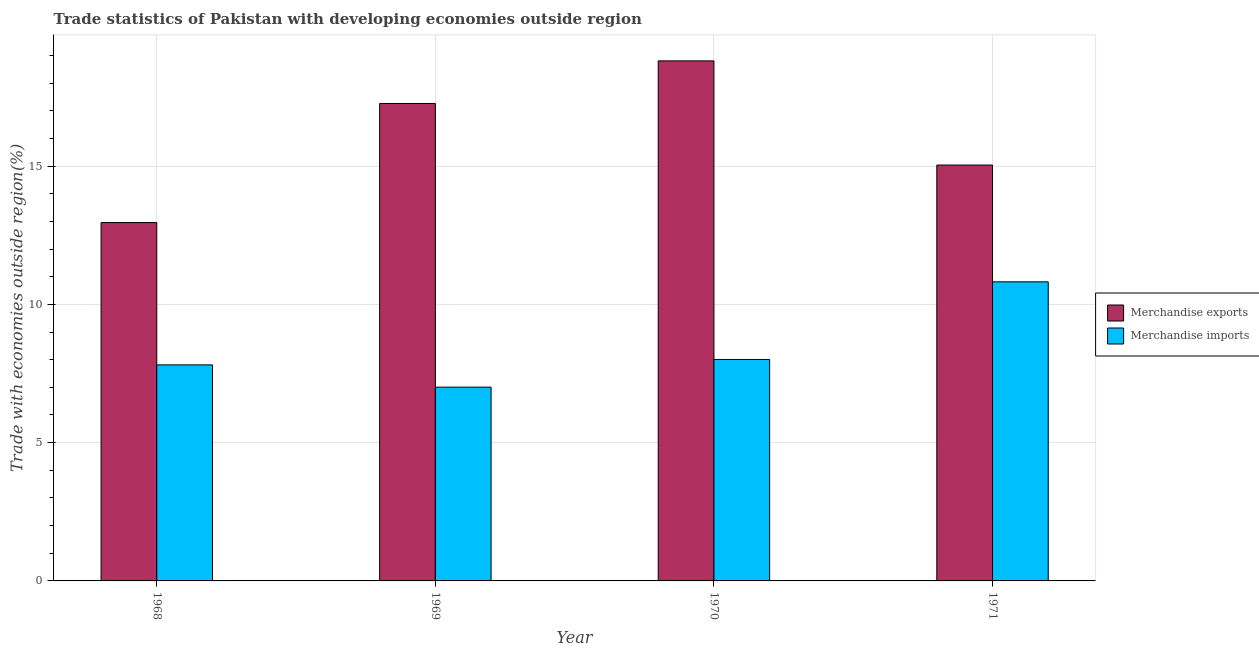How many different coloured bars are there?
Your answer should be compact. 2. How many bars are there on the 2nd tick from the right?
Your answer should be very brief. 2. What is the label of the 1st group of bars from the left?
Provide a short and direct response. 1968. What is the merchandise exports in 1971?
Offer a very short reply. 15.04. Across all years, what is the maximum merchandise exports?
Offer a terse response. 18.8. Across all years, what is the minimum merchandise exports?
Make the answer very short. 12.96. In which year was the merchandise imports maximum?
Ensure brevity in your answer.  1971. In which year was the merchandise imports minimum?
Provide a succinct answer. 1969. What is the total merchandise exports in the graph?
Your answer should be very brief. 64.06. What is the difference between the merchandise exports in 1968 and that in 1969?
Provide a succinct answer. -4.31. What is the difference between the merchandise exports in 1969 and the merchandise imports in 1970?
Your answer should be very brief. -1.54. What is the average merchandise exports per year?
Your response must be concise. 16.02. In the year 1971, what is the difference between the merchandise imports and merchandise exports?
Your answer should be compact. 0. In how many years, is the merchandise imports greater than 4 %?
Provide a short and direct response. 4. What is the ratio of the merchandise imports in 1969 to that in 1970?
Provide a short and direct response. 0.88. What is the difference between the highest and the second highest merchandise imports?
Keep it short and to the point. 2.81. What is the difference between the highest and the lowest merchandise imports?
Make the answer very short. 3.81. Is the sum of the merchandise imports in 1970 and 1971 greater than the maximum merchandise exports across all years?
Offer a terse response. Yes. What does the 2nd bar from the left in 1971 represents?
Your response must be concise. Merchandise imports. What does the 2nd bar from the right in 1971 represents?
Offer a terse response. Merchandise exports. How many bars are there?
Give a very brief answer. 8. How many years are there in the graph?
Provide a short and direct response. 4. What is the difference between two consecutive major ticks on the Y-axis?
Offer a terse response. 5. Are the values on the major ticks of Y-axis written in scientific E-notation?
Your response must be concise. No. Where does the legend appear in the graph?
Provide a short and direct response. Center right. How many legend labels are there?
Your answer should be compact. 2. How are the legend labels stacked?
Offer a terse response. Vertical. What is the title of the graph?
Offer a terse response. Trade statistics of Pakistan with developing economies outside region. What is the label or title of the Y-axis?
Keep it short and to the point. Trade with economies outside region(%). What is the Trade with economies outside region(%) of Merchandise exports in 1968?
Provide a succinct answer. 12.96. What is the Trade with economies outside region(%) in Merchandise imports in 1968?
Offer a terse response. 7.81. What is the Trade with economies outside region(%) in Merchandise exports in 1969?
Offer a very short reply. 17.26. What is the Trade with economies outside region(%) of Merchandise imports in 1969?
Give a very brief answer. 7.01. What is the Trade with economies outside region(%) in Merchandise exports in 1970?
Keep it short and to the point. 18.8. What is the Trade with economies outside region(%) of Merchandise imports in 1970?
Provide a short and direct response. 8.01. What is the Trade with economies outside region(%) in Merchandise exports in 1971?
Your answer should be compact. 15.04. What is the Trade with economies outside region(%) of Merchandise imports in 1971?
Your response must be concise. 10.81. Across all years, what is the maximum Trade with economies outside region(%) in Merchandise exports?
Keep it short and to the point. 18.8. Across all years, what is the maximum Trade with economies outside region(%) of Merchandise imports?
Provide a short and direct response. 10.81. Across all years, what is the minimum Trade with economies outside region(%) in Merchandise exports?
Provide a succinct answer. 12.96. Across all years, what is the minimum Trade with economies outside region(%) of Merchandise imports?
Your answer should be compact. 7.01. What is the total Trade with economies outside region(%) in Merchandise exports in the graph?
Your response must be concise. 64.06. What is the total Trade with economies outside region(%) in Merchandise imports in the graph?
Ensure brevity in your answer.  33.64. What is the difference between the Trade with economies outside region(%) in Merchandise exports in 1968 and that in 1969?
Provide a succinct answer. -4.31. What is the difference between the Trade with economies outside region(%) in Merchandise imports in 1968 and that in 1969?
Offer a very short reply. 0.8. What is the difference between the Trade with economies outside region(%) in Merchandise exports in 1968 and that in 1970?
Offer a very short reply. -5.85. What is the difference between the Trade with economies outside region(%) of Merchandise imports in 1968 and that in 1970?
Offer a terse response. -0.2. What is the difference between the Trade with economies outside region(%) of Merchandise exports in 1968 and that in 1971?
Your answer should be very brief. -2.08. What is the difference between the Trade with economies outside region(%) of Merchandise imports in 1968 and that in 1971?
Your answer should be very brief. -3. What is the difference between the Trade with economies outside region(%) of Merchandise exports in 1969 and that in 1970?
Offer a terse response. -1.54. What is the difference between the Trade with economies outside region(%) of Merchandise imports in 1969 and that in 1970?
Your response must be concise. -1. What is the difference between the Trade with economies outside region(%) in Merchandise exports in 1969 and that in 1971?
Make the answer very short. 2.23. What is the difference between the Trade with economies outside region(%) of Merchandise imports in 1969 and that in 1971?
Provide a succinct answer. -3.81. What is the difference between the Trade with economies outside region(%) in Merchandise exports in 1970 and that in 1971?
Your response must be concise. 3.77. What is the difference between the Trade with economies outside region(%) in Merchandise imports in 1970 and that in 1971?
Offer a terse response. -2.81. What is the difference between the Trade with economies outside region(%) of Merchandise exports in 1968 and the Trade with economies outside region(%) of Merchandise imports in 1969?
Offer a terse response. 5.95. What is the difference between the Trade with economies outside region(%) in Merchandise exports in 1968 and the Trade with economies outside region(%) in Merchandise imports in 1970?
Give a very brief answer. 4.95. What is the difference between the Trade with economies outside region(%) in Merchandise exports in 1968 and the Trade with economies outside region(%) in Merchandise imports in 1971?
Offer a terse response. 2.14. What is the difference between the Trade with economies outside region(%) of Merchandise exports in 1969 and the Trade with economies outside region(%) of Merchandise imports in 1970?
Provide a succinct answer. 9.26. What is the difference between the Trade with economies outside region(%) in Merchandise exports in 1969 and the Trade with economies outside region(%) in Merchandise imports in 1971?
Provide a short and direct response. 6.45. What is the difference between the Trade with economies outside region(%) in Merchandise exports in 1970 and the Trade with economies outside region(%) in Merchandise imports in 1971?
Offer a very short reply. 7.99. What is the average Trade with economies outside region(%) of Merchandise exports per year?
Ensure brevity in your answer.  16.02. What is the average Trade with economies outside region(%) in Merchandise imports per year?
Offer a very short reply. 8.41. In the year 1968, what is the difference between the Trade with economies outside region(%) of Merchandise exports and Trade with economies outside region(%) of Merchandise imports?
Provide a short and direct response. 5.15. In the year 1969, what is the difference between the Trade with economies outside region(%) in Merchandise exports and Trade with economies outside region(%) in Merchandise imports?
Give a very brief answer. 10.26. In the year 1970, what is the difference between the Trade with economies outside region(%) of Merchandise exports and Trade with economies outside region(%) of Merchandise imports?
Offer a terse response. 10.8. In the year 1971, what is the difference between the Trade with economies outside region(%) of Merchandise exports and Trade with economies outside region(%) of Merchandise imports?
Offer a very short reply. 4.22. What is the ratio of the Trade with economies outside region(%) of Merchandise exports in 1968 to that in 1969?
Your answer should be very brief. 0.75. What is the ratio of the Trade with economies outside region(%) in Merchandise imports in 1968 to that in 1969?
Provide a succinct answer. 1.11. What is the ratio of the Trade with economies outside region(%) of Merchandise exports in 1968 to that in 1970?
Provide a succinct answer. 0.69. What is the ratio of the Trade with economies outside region(%) in Merchandise imports in 1968 to that in 1970?
Your answer should be very brief. 0.98. What is the ratio of the Trade with economies outside region(%) of Merchandise exports in 1968 to that in 1971?
Give a very brief answer. 0.86. What is the ratio of the Trade with economies outside region(%) of Merchandise imports in 1968 to that in 1971?
Offer a terse response. 0.72. What is the ratio of the Trade with economies outside region(%) of Merchandise exports in 1969 to that in 1970?
Give a very brief answer. 0.92. What is the ratio of the Trade with economies outside region(%) of Merchandise imports in 1969 to that in 1970?
Your answer should be very brief. 0.88. What is the ratio of the Trade with economies outside region(%) of Merchandise exports in 1969 to that in 1971?
Offer a terse response. 1.15. What is the ratio of the Trade with economies outside region(%) of Merchandise imports in 1969 to that in 1971?
Provide a short and direct response. 0.65. What is the ratio of the Trade with economies outside region(%) in Merchandise exports in 1970 to that in 1971?
Your answer should be very brief. 1.25. What is the ratio of the Trade with economies outside region(%) of Merchandise imports in 1970 to that in 1971?
Provide a short and direct response. 0.74. What is the difference between the highest and the second highest Trade with economies outside region(%) in Merchandise exports?
Your answer should be very brief. 1.54. What is the difference between the highest and the second highest Trade with economies outside region(%) of Merchandise imports?
Ensure brevity in your answer.  2.81. What is the difference between the highest and the lowest Trade with economies outside region(%) in Merchandise exports?
Provide a short and direct response. 5.85. What is the difference between the highest and the lowest Trade with economies outside region(%) in Merchandise imports?
Provide a short and direct response. 3.81. 